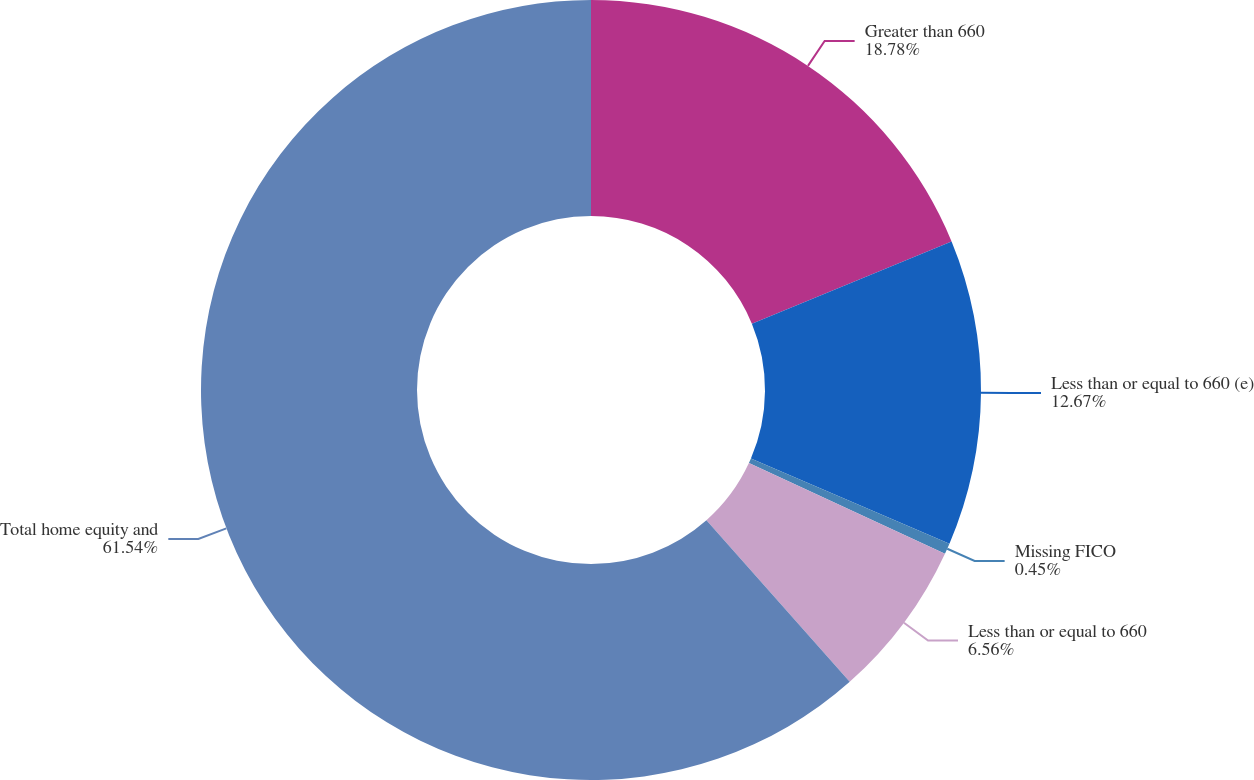Convert chart to OTSL. <chart><loc_0><loc_0><loc_500><loc_500><pie_chart><fcel>Greater than 660<fcel>Less than or equal to 660 (e)<fcel>Missing FICO<fcel>Less than or equal to 660<fcel>Total home equity and<nl><fcel>18.78%<fcel>12.67%<fcel>0.45%<fcel>6.56%<fcel>61.55%<nl></chart> 